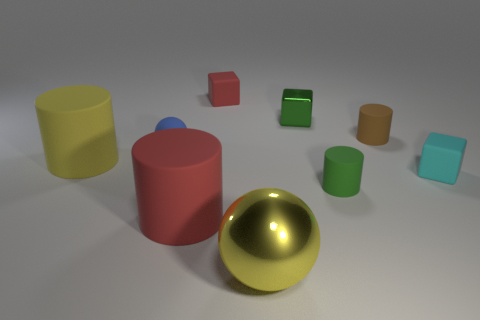Subtract all purple blocks. Subtract all gray spheres. How many blocks are left? 3 Subtract all cylinders. How many objects are left? 5 Add 4 large yellow rubber things. How many large yellow rubber things exist? 5 Subtract 1 yellow spheres. How many objects are left? 8 Subtract all yellow blocks. Subtract all matte blocks. How many objects are left? 7 Add 6 green shiny things. How many green shiny things are left? 7 